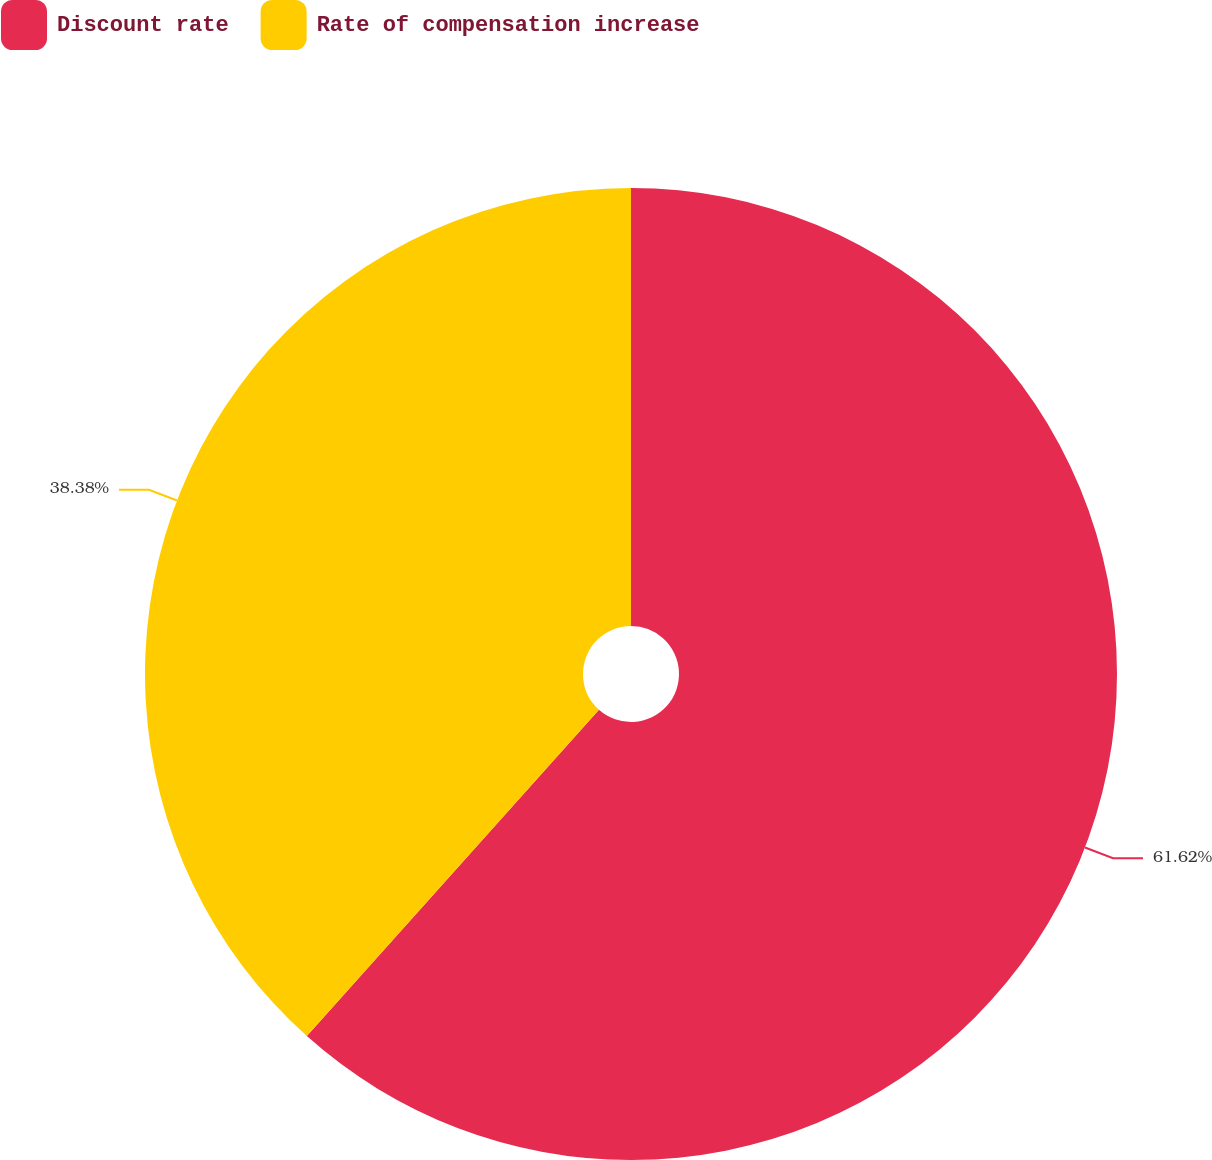Convert chart. <chart><loc_0><loc_0><loc_500><loc_500><pie_chart><fcel>Discount rate<fcel>Rate of compensation increase<nl><fcel>61.62%<fcel>38.38%<nl></chart> 